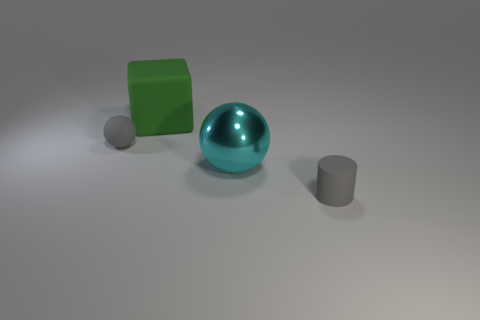How many cylinders are either large green things or large cyan things?
Your answer should be compact. 0. What color is the tiny matte cylinder?
Offer a terse response. Gray. Are there more gray rubber cylinders than green balls?
Your response must be concise. Yes. How many things are small matte objects that are right of the cyan object or cubes?
Your answer should be compact. 2. Are the big green block and the cyan object made of the same material?
Your response must be concise. No. There is another rubber thing that is the same shape as the cyan thing; what is its size?
Your answer should be compact. Small. There is a gray object that is to the left of the gray cylinder; is its shape the same as the big cyan metallic thing behind the cylinder?
Make the answer very short. Yes. Do the gray cylinder and the gray thing that is left of the green rubber cube have the same size?
Offer a very short reply. Yes. What number of other objects are the same material as the tiny gray sphere?
Provide a succinct answer. 2. Are there any other things that are the same shape as the big green thing?
Ensure brevity in your answer.  No. 